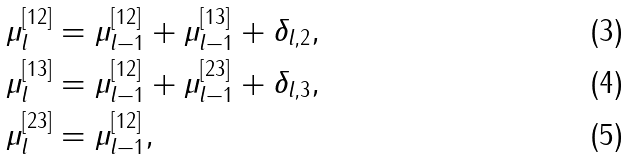Convert formula to latex. <formula><loc_0><loc_0><loc_500><loc_500>\mu _ { l } ^ { [ 1 2 ] } & = \mu _ { l - 1 } ^ { [ 1 2 ] } + \mu _ { l - 1 } ^ { [ 1 3 ] } + \delta _ { l , 2 } , \\ \mu _ { l } ^ { [ 1 3 ] } & = \mu _ { l - 1 } ^ { [ 1 2 ] } + \mu _ { l - 1 } ^ { [ 2 3 ] } + \delta _ { l , 3 } , \\ \mu _ { l } ^ { [ 2 3 ] } & = \mu _ { l - 1 } ^ { [ 1 2 ] } ,</formula> 